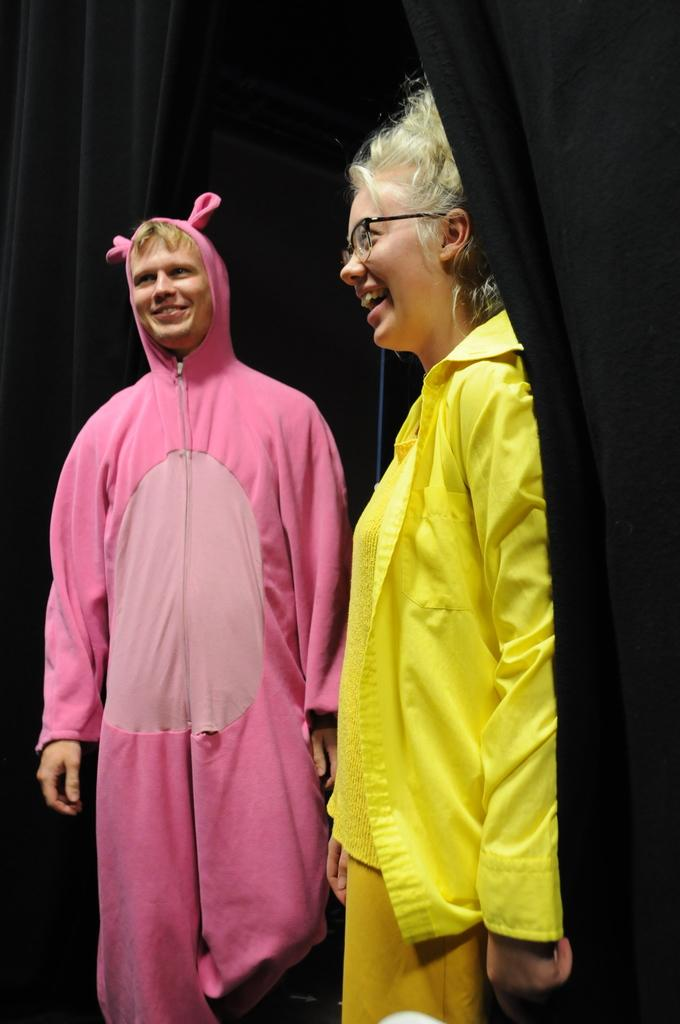What is the man in the image wearing? The man is wearing a pink dress. What is the woman in the image wearing? The woman is wearing a yellow dress. What are the facial expressions of the man and woman in the image? The man and woman are both standing and smiling. What can be seen in the background of the image? There are black curtains in the image. How much salt is visible on the man's dress in the image? There is no salt visible on the man's dress in the image. What type of sugar is present on the woman's dress in the image? There is no sugar present on the woman's dress in the image. 